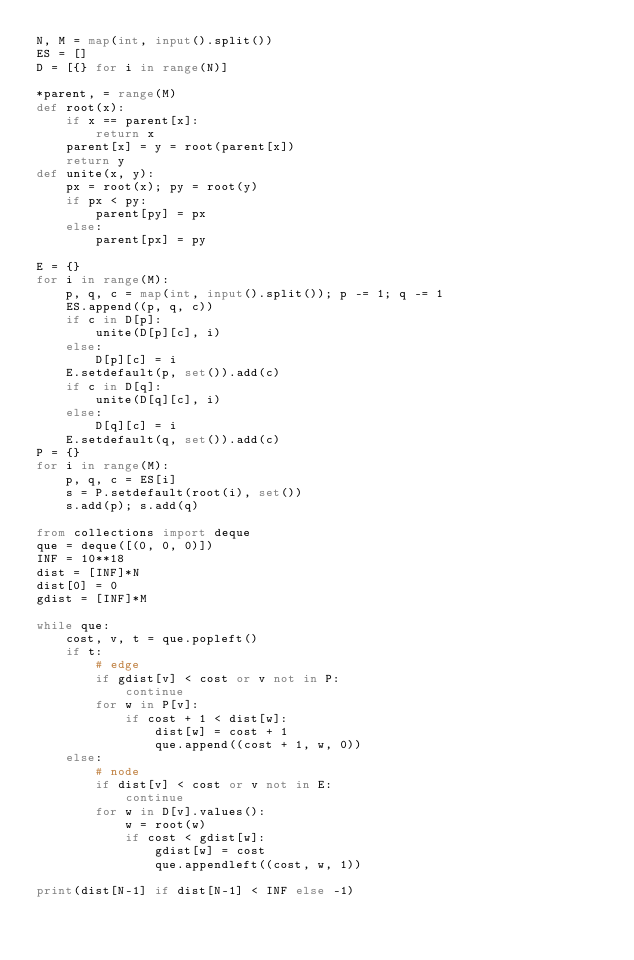Convert code to text. <code><loc_0><loc_0><loc_500><loc_500><_Python_>N, M = map(int, input().split())
ES = []
D = [{} for i in range(N)]

*parent, = range(M)
def root(x):
    if x == parent[x]:
        return x
    parent[x] = y = root(parent[x])
    return y
def unite(x, y):
    px = root(x); py = root(y)
    if px < py:
        parent[py] = px
    else:
        parent[px] = py

E = {}
for i in range(M):
    p, q, c = map(int, input().split()); p -= 1; q -= 1
    ES.append((p, q, c))
    if c in D[p]:
        unite(D[p][c], i)
    else:
        D[p][c] = i
    E.setdefault(p, set()).add(c)
    if c in D[q]:
        unite(D[q][c], i)
    else:
        D[q][c] = i
    E.setdefault(q, set()).add(c)
P = {}
for i in range(M):
    p, q, c = ES[i]
    s = P.setdefault(root(i), set())
    s.add(p); s.add(q)

from collections import deque
que = deque([(0, 0, 0)])
INF = 10**18
dist = [INF]*N
dist[0] = 0
gdist = [INF]*M

while que:
    cost, v, t = que.popleft()
    if t:
        # edge
        if gdist[v] < cost or v not in P:
            continue
        for w in P[v]:
            if cost + 1 < dist[w]:
                dist[w] = cost + 1
                que.append((cost + 1, w, 0))
    else:
        # node
        if dist[v] < cost or v not in E:
            continue
        for w in D[v].values():
            w = root(w)
            if cost < gdist[w]:
                gdist[w] = cost
                que.appendleft((cost, w, 1))

print(dist[N-1] if dist[N-1] < INF else -1)
</code> 